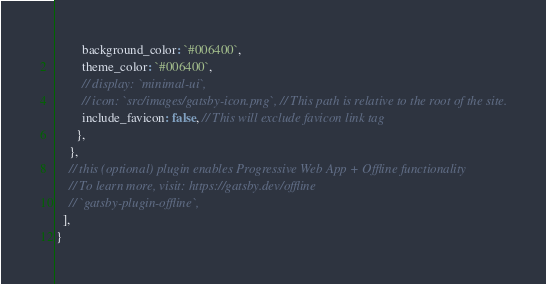Convert code to text. <code><loc_0><loc_0><loc_500><loc_500><_JavaScript_>        background_color: `#006400`,
        theme_color: `#006400`,
        // display: `minimal-ui`,
        // icon: `src/images/gatsby-icon.png`, // This path is relative to the root of the site.
        include_favicon: false, // This will exclude favicon link tag
      },
    },
    // this (optional) plugin enables Progressive Web App + Offline functionality
    // To learn more, visit: https://gatsby.dev/offline
    // `gatsby-plugin-offline`,
  ],
}
</code> 